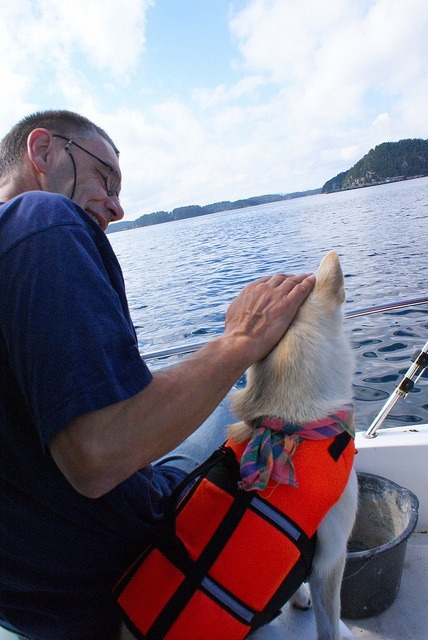Describe the objects in this image and their specific colors. I can see people in white, black, gray, navy, and maroon tones, dog in white, black, maroon, and darkgray tones, and boat in white, black, darkgray, and gray tones in this image. 